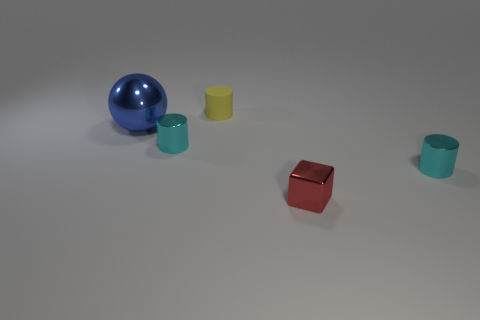Is there anything else that is the same shape as the red thing?
Your answer should be compact. No. What number of things are tiny things that are behind the small metal cube or small rubber cylinders?
Give a very brief answer. 3. Is there a metallic object of the same shape as the small yellow matte object?
Offer a very short reply. Yes. Is the number of large blue objects to the right of the ball the same as the number of small brown metallic objects?
Offer a terse response. Yes. What number of other yellow things have the same size as the rubber thing?
Offer a very short reply. 0. There is a large blue ball; how many small red things are behind it?
Offer a terse response. 0. There is a cyan thing in front of the small cyan metallic cylinder that is on the left side of the small rubber cylinder; what is its material?
Your response must be concise. Metal. There is a cube that is made of the same material as the large thing; what is its size?
Provide a succinct answer. Small. Are there any other things that have the same color as the small rubber cylinder?
Keep it short and to the point. No. What color is the small matte cylinder that is behind the red cube?
Offer a terse response. Yellow. 